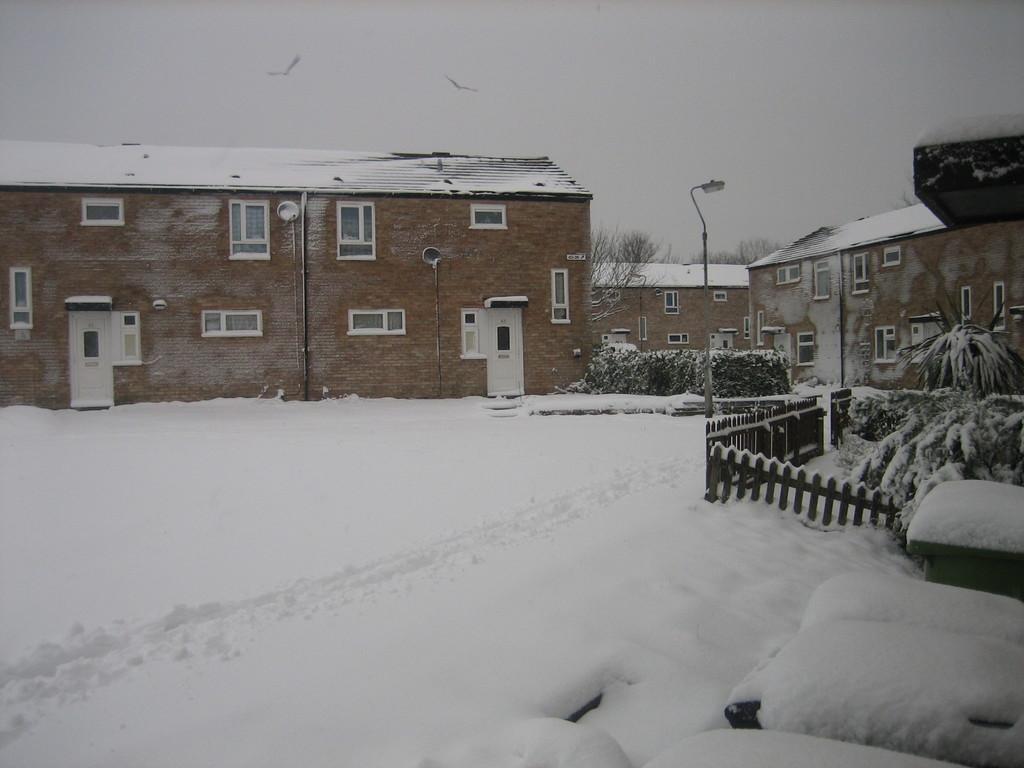Describe this image in one or two sentences. In this image I can see few buildings, windows, doors, snow, plants, fencing, poles, sky and few birds are flying in the air. 